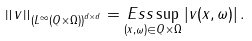<formula> <loc_0><loc_0><loc_500><loc_500>\left \| v \right \| _ { \left ( L ^ { \infty } ( Q \times \Omega ) \right ) ^ { d \times d } } = \underset { ( x , \omega ) \in Q \times \Omega } { E s s \sup } \left | v ( x , \omega ) \right | .</formula> 